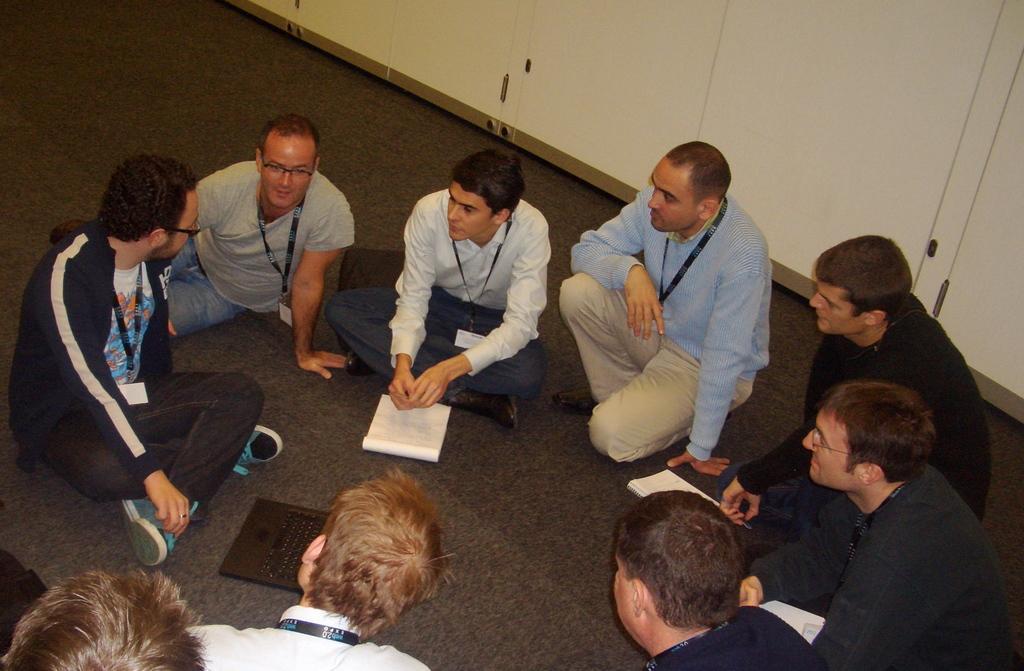Describe this image in one or two sentences. In this picture there are some group of boys sitting on the flooring mat and discussing something. Behind we can see white color wardrobe doors. 